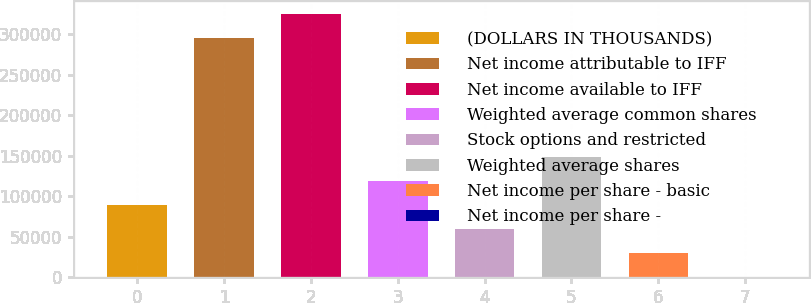Convert chart to OTSL. <chart><loc_0><loc_0><loc_500><loc_500><bar_chart><fcel>(DOLLARS IN THOUSANDS)<fcel>Net income attributable to IFF<fcel>Net income available to IFF<fcel>Weighted average common shares<fcel>Stock options and restricted<fcel>Weighted average shares<fcel>Net income per share - basic<fcel>Net income per share -<nl><fcel>88702.1<fcel>295665<fcel>325231<fcel>118268<fcel>59136<fcel>147834<fcel>29569.8<fcel>3.72<nl></chart> 